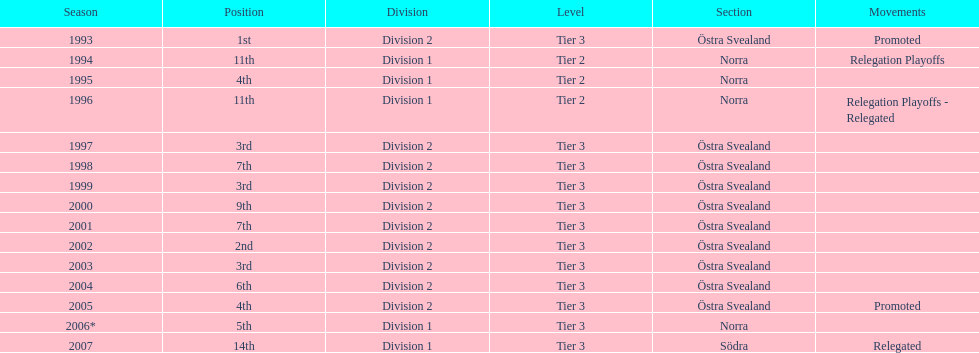What is listed under the movements column of the last season? Relegated. 